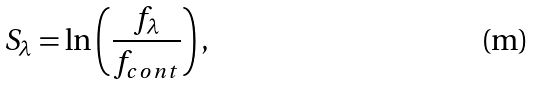Convert formula to latex. <formula><loc_0><loc_0><loc_500><loc_500>S _ { \lambda } = \ln \left ( \frac { f _ { \lambda } } { f _ { c o n t } } \right ) ,</formula> 